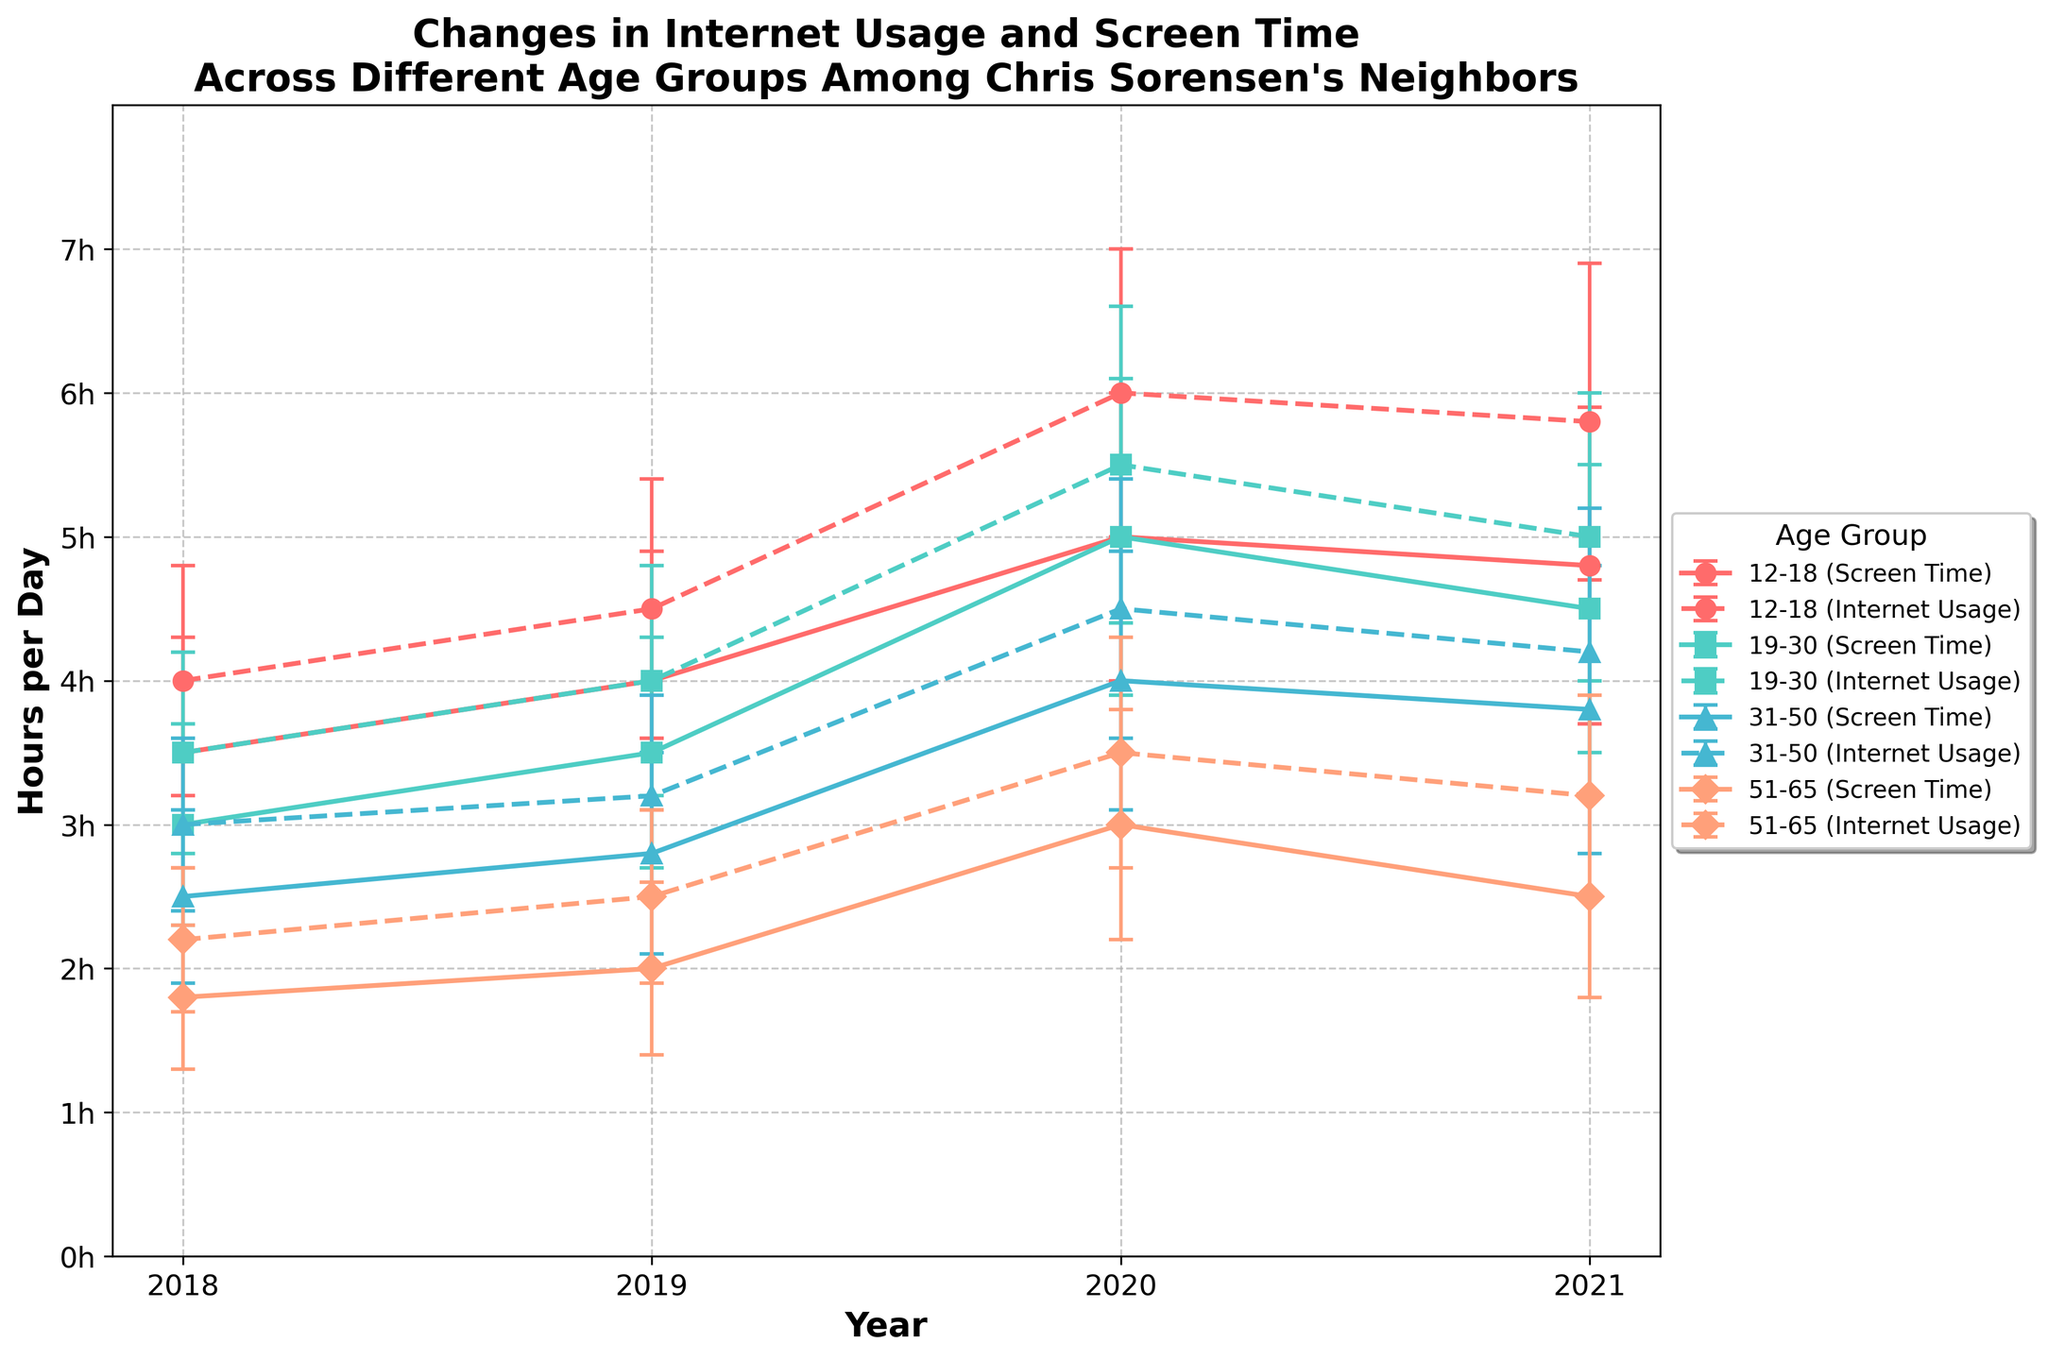What is the title of the plot? The title of the plot is usually written at the top and summarizes the main idea of the chart. Here, it is "Changes in Internet Usage and Screen Time Across Different Age Groups Among Chris Sorensen's Neighbors".
Answer: "Changes in Internet Usage and Screen Time Across Different Age Groups Among Chris Sorensen's Neighbors" What is the time range represented on the x-axis? The x-axis represents the years, ranging from 2018 to 2021. This can be seen from the ticks labeled "2018, 2019, 2020, 2021".
Answer: 2018 to 2021 In 2020, which age group had the highest Average Screen Time? By examining the 2020 data points for each age group on the plot, we see that the 12-18 age group has the highest average screen time value near 5 hours per day.
Answer: 12-18 Which age group shows the biggest increase in Average Internet Usage from 2018 to 2019? To determine the biggest increase, we calculate the difference between 2018 and 2019 for each age group and compare them. The 12-18 age group increases from 4.0 to 4.5 hours, which is 0.5 hours—this is the highest increase.
Answer: 12-18 How did the Average Screen Time for the 19-30 age group change from 2020 to 2021? For the 19-30 age group, the Average Screen Time in 2020 is higher compared to 2021. We see that it decreases from 5.0 hours in 2020 to 4.5 hours in 2021, a decrease of 0.5 hours.
Answer: Decreased by 0.5 hours Which age group had the smallest standard deviation in Internet Usage in 2021? The standard deviation in Internet Usage for 2021 for each age group can be seen through error bars—the 51-65 age group has the smallest error bar, indicating a standard deviation of approximately 0.8 hours.
Answer: 51-65 Compare the trend of Average Internet Usage for the 31-50 age group to the 51-65 age group from 2018 to 2021. Both age groups see an increase in Average Internet Usage from 2018 to 2020. The 31-50 group increases from 3.0 to 4.5 hours, while the 51-65 group increases from 2.2 to 3.5 hours. In 2021, both decreased, with 31-50 reducing to 4.2 hours and 51-65 reducing to 3.2 hours.
Answer: Both groups increase until 2020 then decrease in 2021 What was the Average Screen Time of the 12-18 age group in 2019? For the 12-18 age group in 2019, the plot shows an average screen time of 4.0 hours per day as indicated by the data points and error bars for that year.
Answer: 4.0 hours Identify the year when the 19-30 age group had equal Average Screen Time and Average Internet Usage. On examining the plot for the 19-30 age group, we see in 2020 both the Average Screen Time and Average Internet Usage are 5.0 hours and 5.5 hours per day respectively.
Answer: No year matches this criterion From 2018 to 2021, which age group consistently had the lowest Average Internet Usage? By looking at the Internet Usage lines for all age groups across all years, the 51-65 age group consistently shows the lowest Average Internet Usage.
Answer: 51-65 